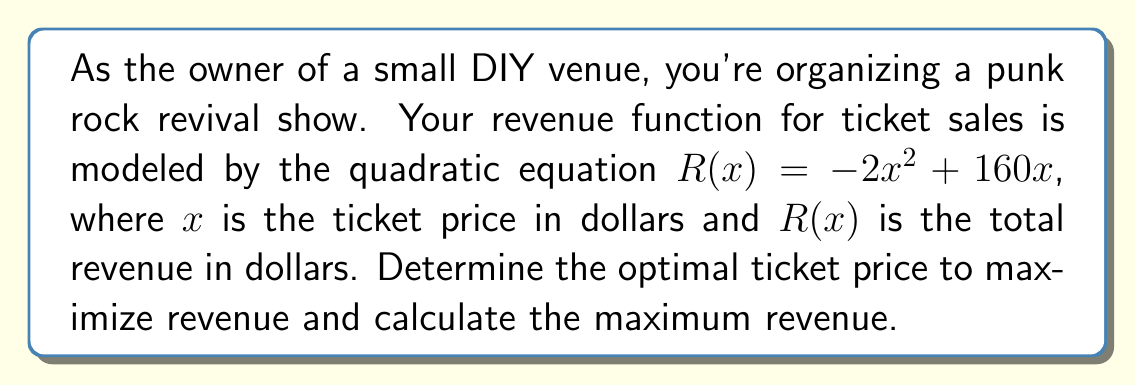Could you help me with this problem? To solve this problem, we'll follow these steps:

1) The revenue function is given as $R(x) = -2x^2 + 160x$

2) To find the maximum revenue, we need to find the vertex of this parabola. The x-coordinate of the vertex will give us the optimal ticket price.

3) For a quadratic function in the form $ax^2 + bx + c$, the x-coordinate of the vertex is given by $-b/(2a)$

4) In our case, $a = -2$ and $b = 160$

5) Optimal price = $-b/(2a) = -160/(-4) = 40$

6) To find the maximum revenue, we substitute this x-value back into our original function:

   $R(40) = -2(40)^2 + 160(40)$
          $= -2(1600) + 6400$
          $= -3200 + 6400$
          $= 3200$

Therefore, the optimal ticket price is $40, and the maximum revenue is $3200.
Answer: Optimal ticket price: $40
Maximum revenue: $3200 